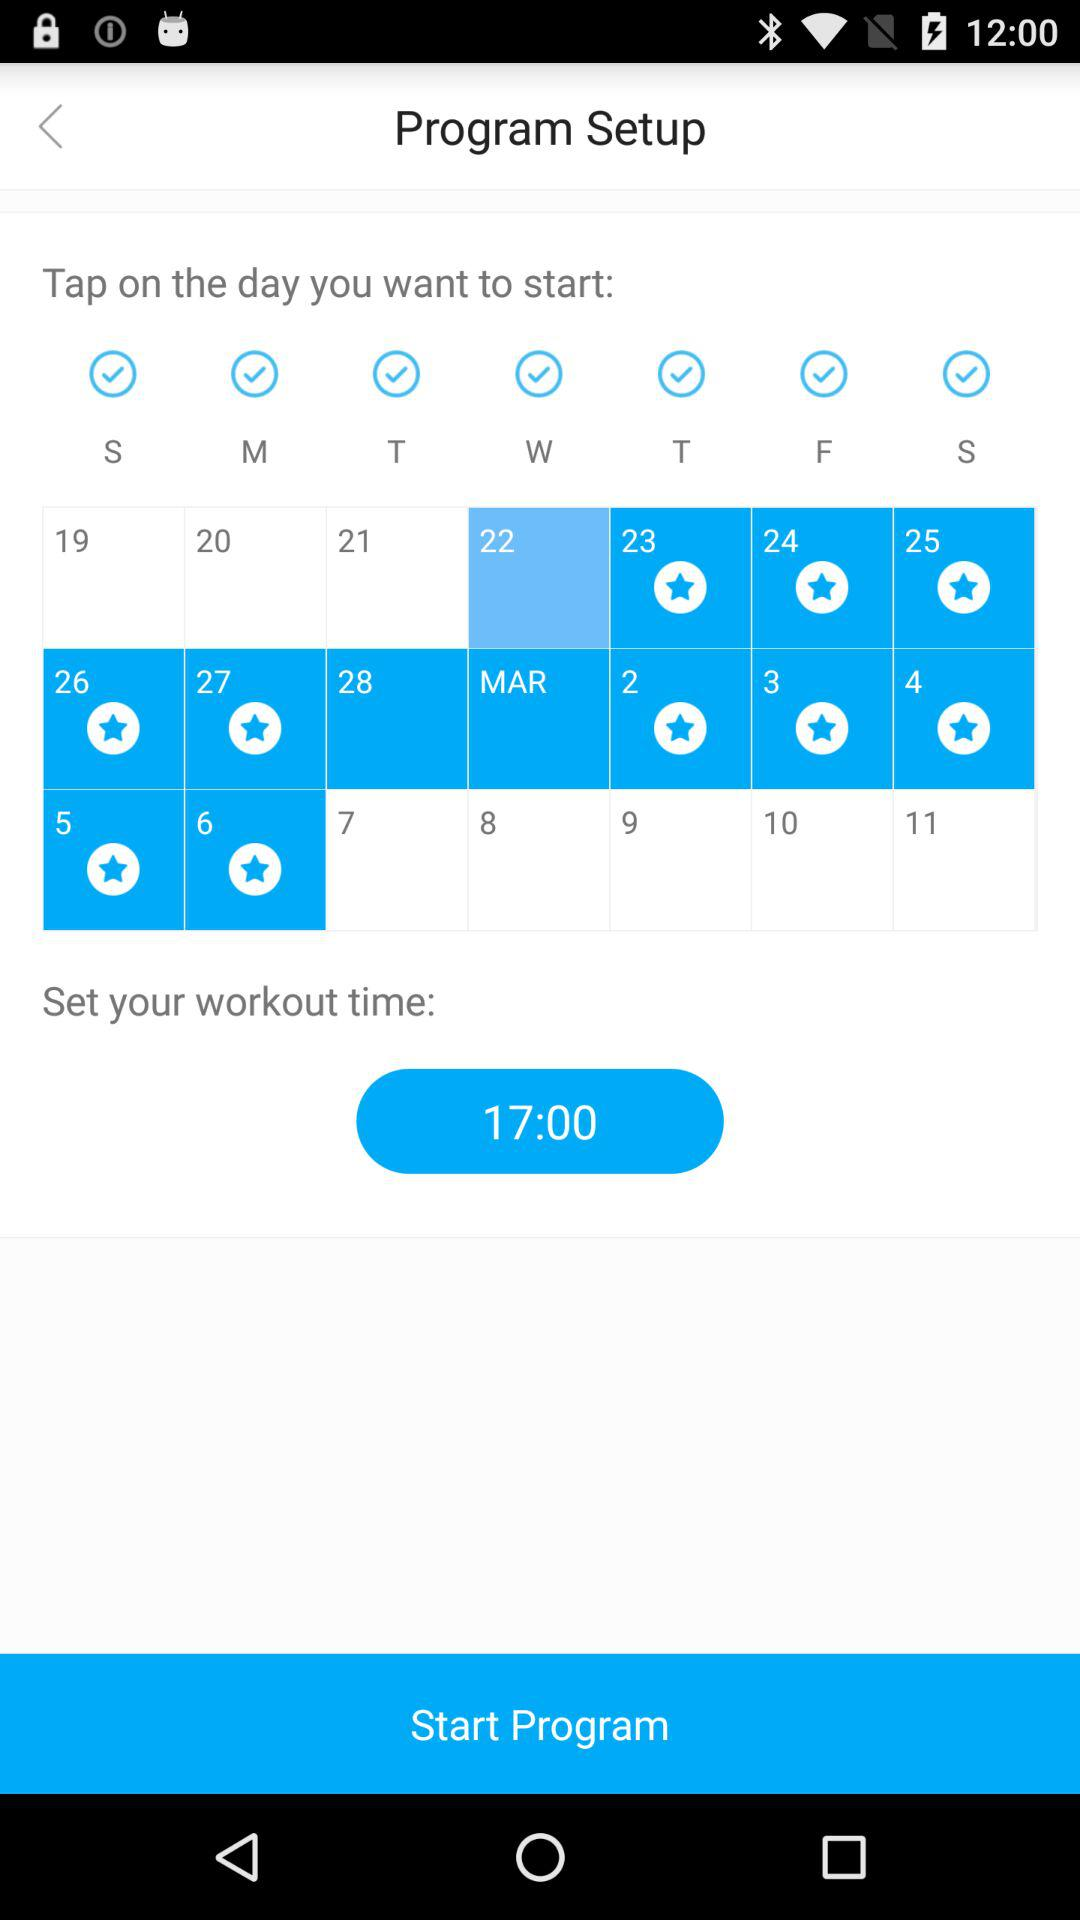What is the starting date of the workout? The starting date is 22. 